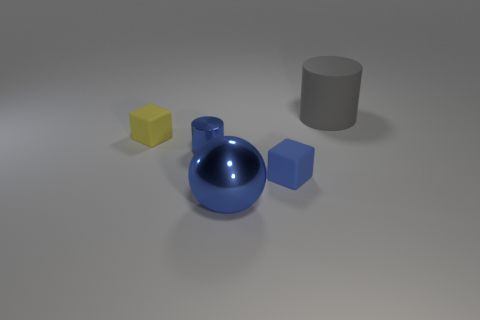Add 3 large cylinders. How many objects exist? 8 Subtract all cylinders. How many objects are left? 3 Subtract 2 blocks. How many blocks are left? 0 Add 5 small blue shiny objects. How many small blue shiny objects are left? 6 Add 4 blue shiny objects. How many blue shiny objects exist? 6 Subtract 0 brown cylinders. How many objects are left? 5 Subtract all blue blocks. Subtract all purple cylinders. How many blocks are left? 1 Subtract all purple cylinders. How many brown balls are left? 0 Subtract all metallic balls. Subtract all small blue cylinders. How many objects are left? 3 